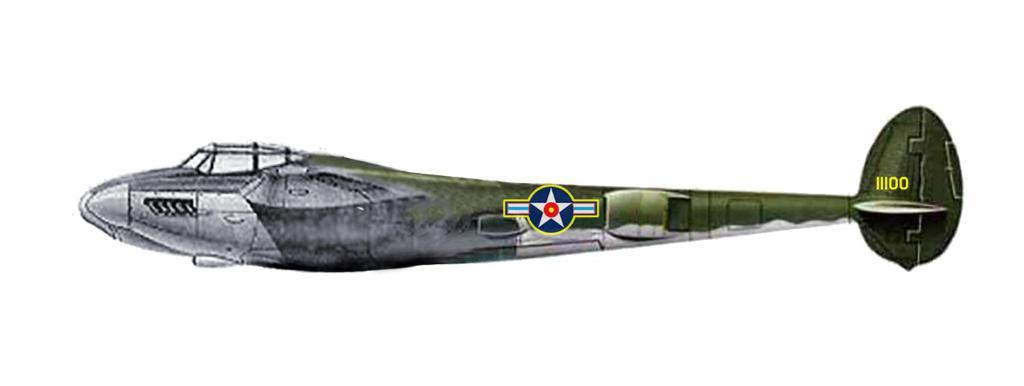What is the main subject of the image? There is a flight in the center of the image. Can you tell me how many people are smiling in the image? There is no information about people or smiling in the image, as it only features a flight. 